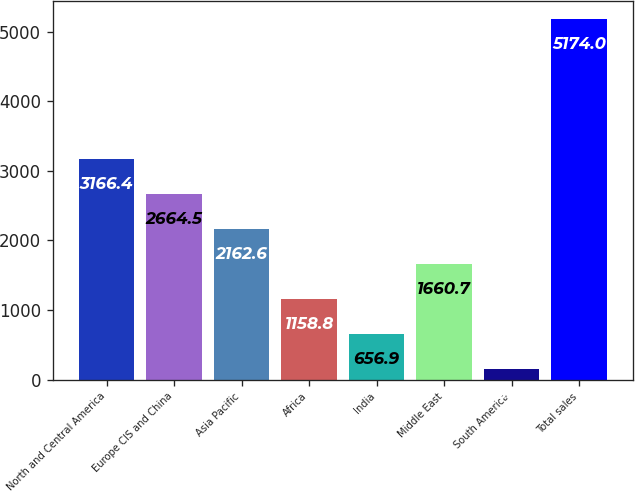<chart> <loc_0><loc_0><loc_500><loc_500><bar_chart><fcel>North and Central America<fcel>Europe CIS and China<fcel>Asia Pacific<fcel>Africa<fcel>India<fcel>Middle East<fcel>South America<fcel>Total sales<nl><fcel>3166.4<fcel>2664.5<fcel>2162.6<fcel>1158.8<fcel>656.9<fcel>1660.7<fcel>155<fcel>5174<nl></chart> 